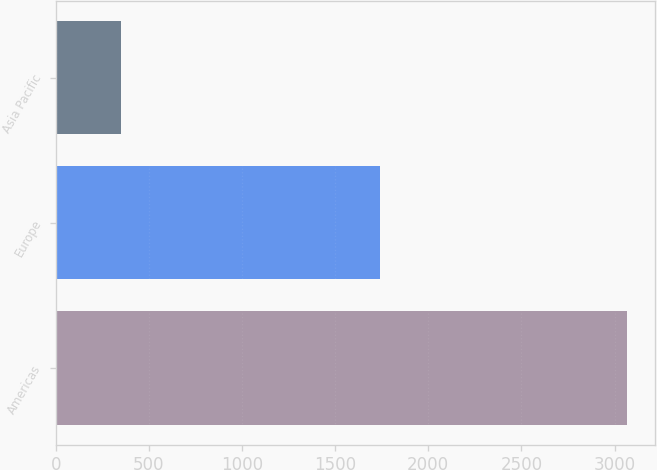<chart> <loc_0><loc_0><loc_500><loc_500><bar_chart><fcel>Americas<fcel>Europe<fcel>Asia Pacific<nl><fcel>3065<fcel>1743<fcel>348<nl></chart> 